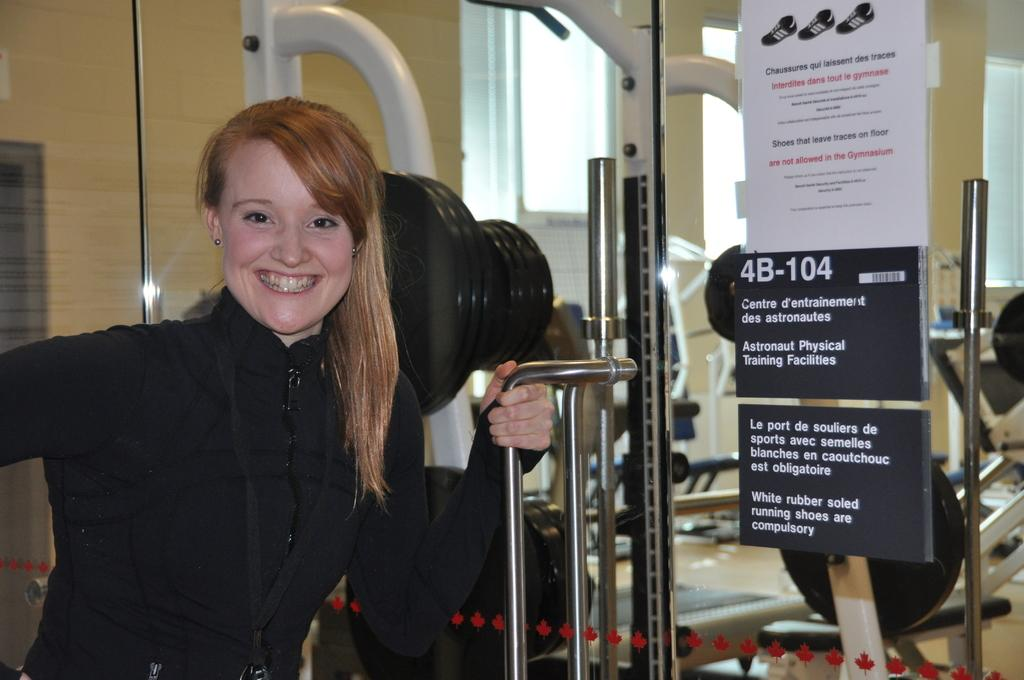What is the main subject of the image? There is a person in the image. What is the person's expression in the image? The person is smiling in the image. What type of architectural feature can be seen in the image? There is a glass door in the image. What type of nose can be seen on the playground in the image? There is no playground or nose present in the image. 